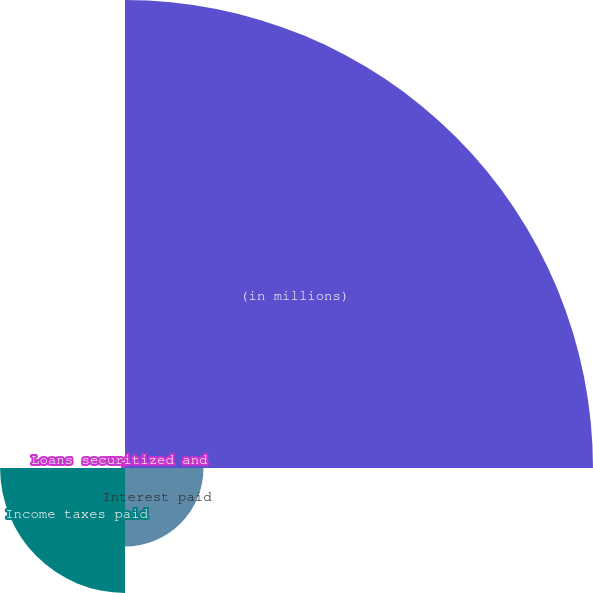Convert chart. <chart><loc_0><loc_0><loc_500><loc_500><pie_chart><fcel>(in millions)<fcel>Interest paid<fcel>Income taxes paid<fcel>Loans securitized and<nl><fcel>69.27%<fcel>11.62%<fcel>18.49%<fcel>0.62%<nl></chart> 